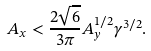<formula> <loc_0><loc_0><loc_500><loc_500>A _ { x } < \frac { 2 \sqrt { 6 } } { 3 \pi } A _ { y } ^ { 1 / 2 } \gamma ^ { 3 / 2 } .</formula> 